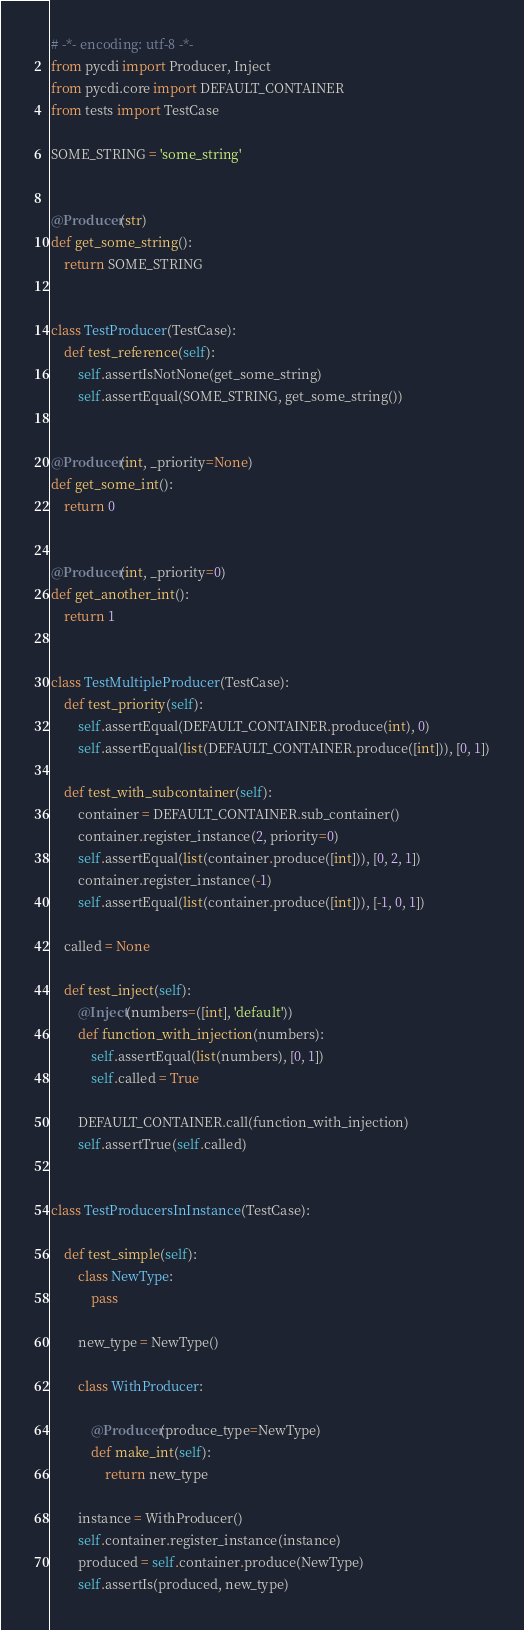Convert code to text. <code><loc_0><loc_0><loc_500><loc_500><_Python_># -*- encoding: utf-8 -*-
from pycdi import Producer, Inject
from pycdi.core import DEFAULT_CONTAINER
from tests import TestCase

SOME_STRING = 'some_string'


@Producer(str)
def get_some_string():
    return SOME_STRING


class TestProducer(TestCase):
    def test_reference(self):
        self.assertIsNotNone(get_some_string)
        self.assertEqual(SOME_STRING, get_some_string())


@Producer(int, _priority=None)
def get_some_int():
    return 0


@Producer(int, _priority=0)
def get_another_int():
    return 1


class TestMultipleProducer(TestCase):
    def test_priority(self):
        self.assertEqual(DEFAULT_CONTAINER.produce(int), 0)
        self.assertEqual(list(DEFAULT_CONTAINER.produce([int])), [0, 1])

    def test_with_subcontainer(self):
        container = DEFAULT_CONTAINER.sub_container()
        container.register_instance(2, priority=0)
        self.assertEqual(list(container.produce([int])), [0, 2, 1])
        container.register_instance(-1)
        self.assertEqual(list(container.produce([int])), [-1, 0, 1])

    called = None

    def test_inject(self):
        @Inject(numbers=([int], 'default'))
        def function_with_injection(numbers):
            self.assertEqual(list(numbers), [0, 1])
            self.called = True

        DEFAULT_CONTAINER.call(function_with_injection)
        self.assertTrue(self.called)


class TestProducersInInstance(TestCase):

    def test_simple(self):
        class NewType:
            pass

        new_type = NewType()

        class WithProducer:

            @Producer(produce_type=NewType)
            def make_int(self):
                return new_type

        instance = WithProducer()
        self.container.register_instance(instance)
        produced = self.container.produce(NewType)
        self.assertIs(produced, new_type)
</code> 